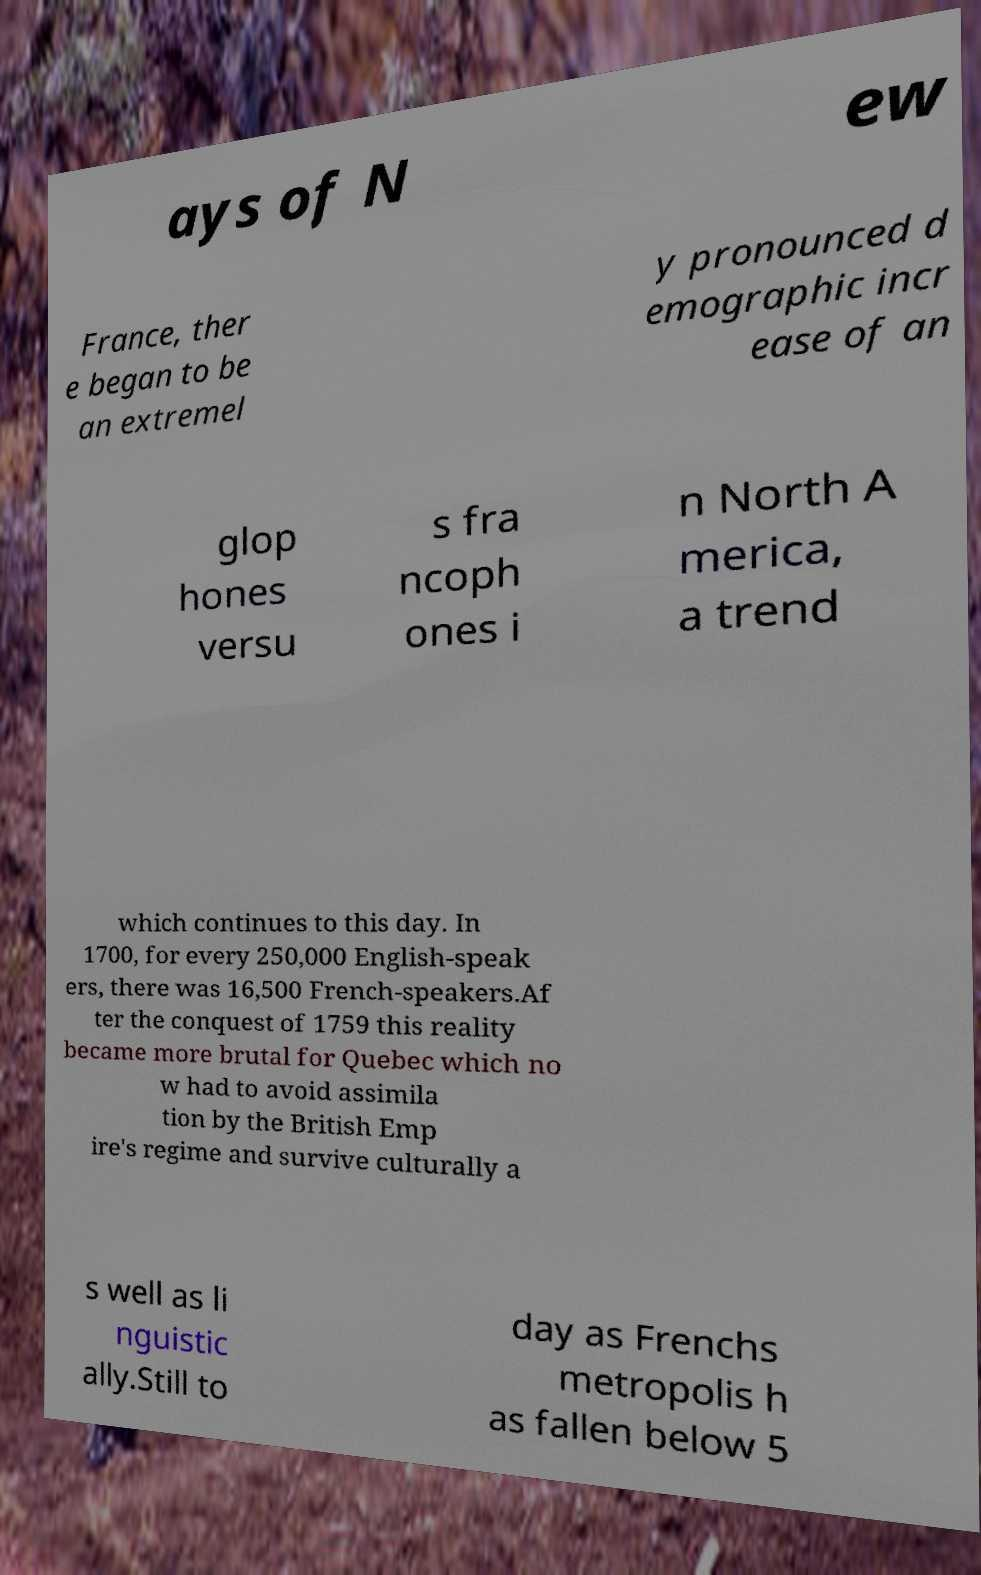What messages or text are displayed in this image? I need them in a readable, typed format. ays of N ew France, ther e began to be an extremel y pronounced d emographic incr ease of an glop hones versu s fra ncoph ones i n North A merica, a trend which continues to this day. In 1700, for every 250,000 English-speak ers, there was 16,500 French-speakers.Af ter the conquest of 1759 this reality became more brutal for Quebec which no w had to avoid assimila tion by the British Emp ire's regime and survive culturally a s well as li nguistic ally.Still to day as Frenchs metropolis h as fallen below 5 